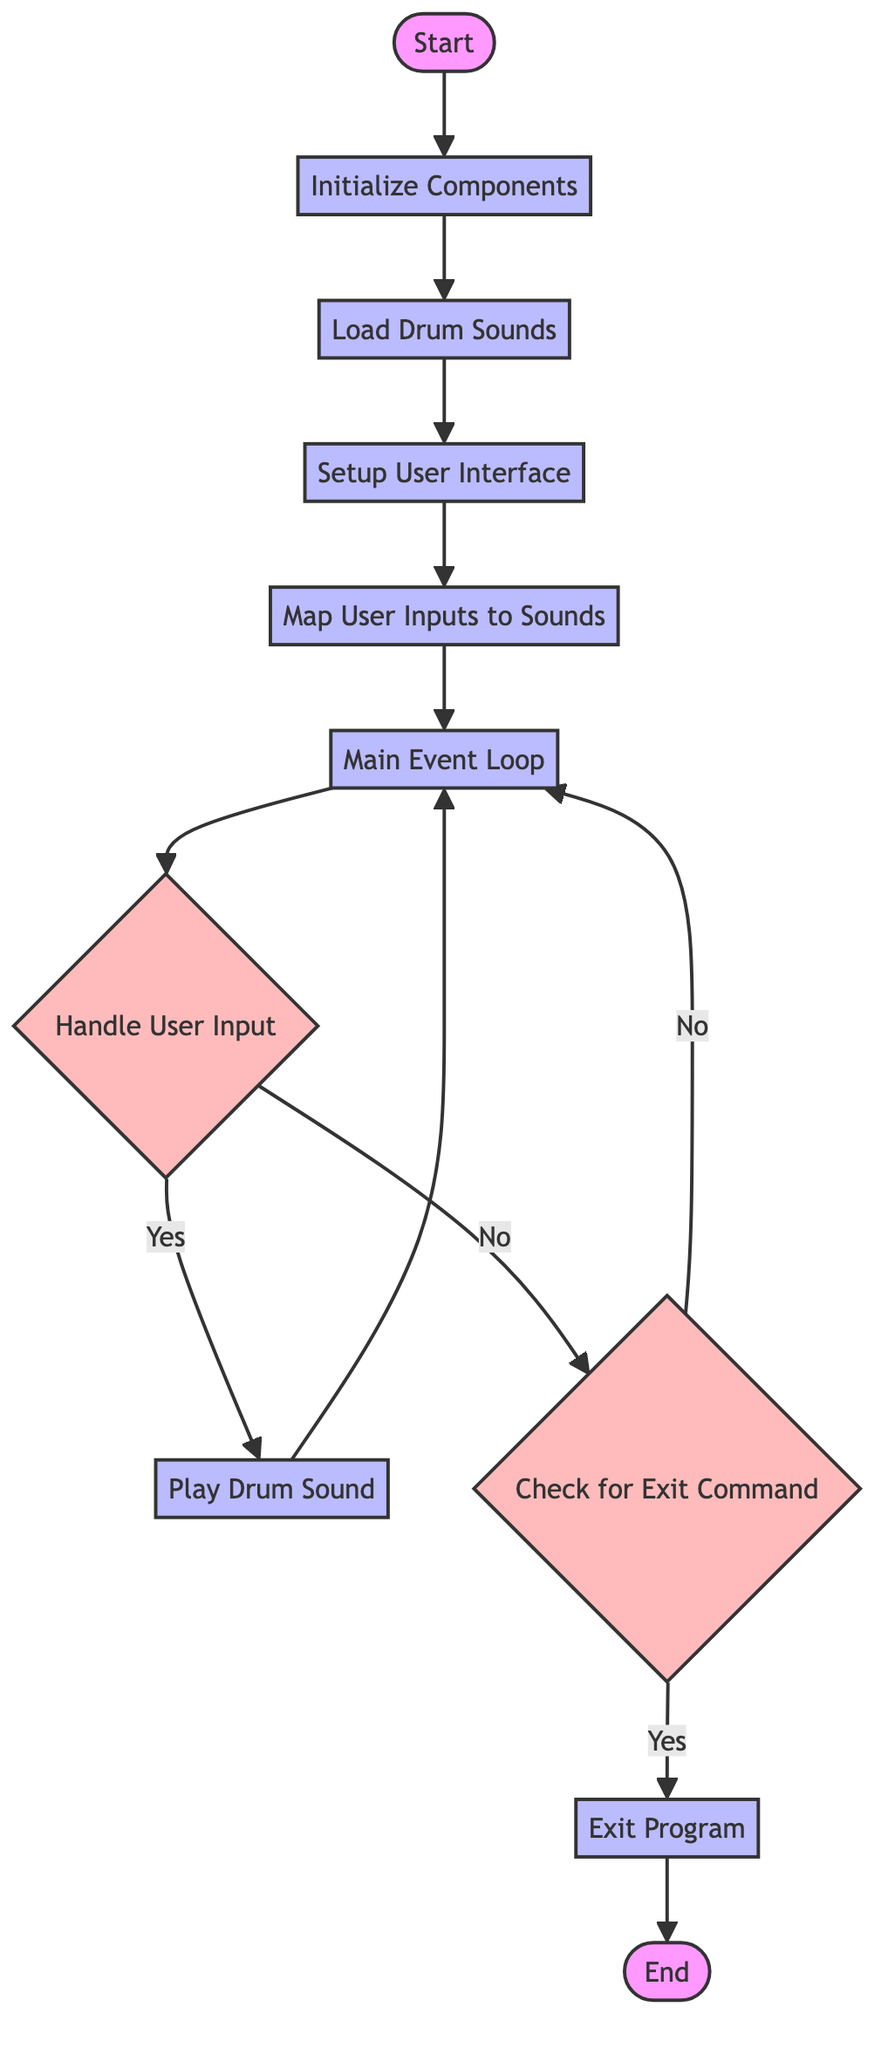What is the first step in the flowchart? The first step in the flowchart is labeled "Start," which indicates the beginning of the process.
Answer: Start How many processes are there in total? By counting the nodes in the diagram labeled as processes, there are five processes: "Initialize Components," "Load Drum Sounds," "Setup User Interface," "Map User Inputs to Sounds," and "Play Drum Sound."
Answer: 5 What decision follows the main event loop? The decision that follows the main event loop is "Handle User Input," where the program checks for user interaction to decide the next action.
Answer: Handle User Input Which process occurs after loading drum sounds? After loading drum sounds, the next process indicated in the flowchart is "Setup User Interface."
Answer: Setup User Interface What happens if the user input does not match the mapped keys? If the user input does not match the mapped keys, the flowchart directs to the decision "Check for Exit Command."
Answer: Check for Exit Command If the user inputs are handled successfully, which process comes next? Upon successful handling of user inputs, the next process is "Play Drum Sound," suggesting that a corresponding sound will play.
Answer: Play Drum Sound What is the final action taken before the program ends? The final action taken before the program ends is "Exit Program," which terminates the event loop and gracefully closes the program.
Answer: Exit Program How many total nodes are in the flowchart? By counting all the elements in the flowchart, including both processes and decisions, there are eleven nodes.
Answer: 11 Which process does the flowchart initially direct to after the start? After the "Start," the flowchart initially directs to "Initialize Components," indicating that the setup of necessary tools begins there.
Answer: Initialize Components 